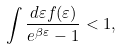<formula> <loc_0><loc_0><loc_500><loc_500>\int \frac { d \varepsilon f ( \varepsilon ) } { e ^ { \beta \varepsilon } - 1 } < 1 ,</formula> 